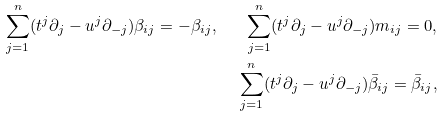<formula> <loc_0><loc_0><loc_500><loc_500>\sum _ { j = 1 } ^ { n } ( t ^ { j } \partial _ { j } - u ^ { j } \partial _ { - j } ) \beta _ { i j } = - \beta _ { i j } , \quad \sum _ { j = 1 } ^ { n } ( t ^ { j } \partial _ { j } - u ^ { j } \partial _ { - j } ) m _ { i j } = 0 , \\ \sum _ { j = 1 } ^ { n } ( t ^ { j } \partial _ { j } - u ^ { j } \partial _ { - j } ) \bar { \beta } _ { i j } = \bar { \beta } _ { i j } ,</formula> 